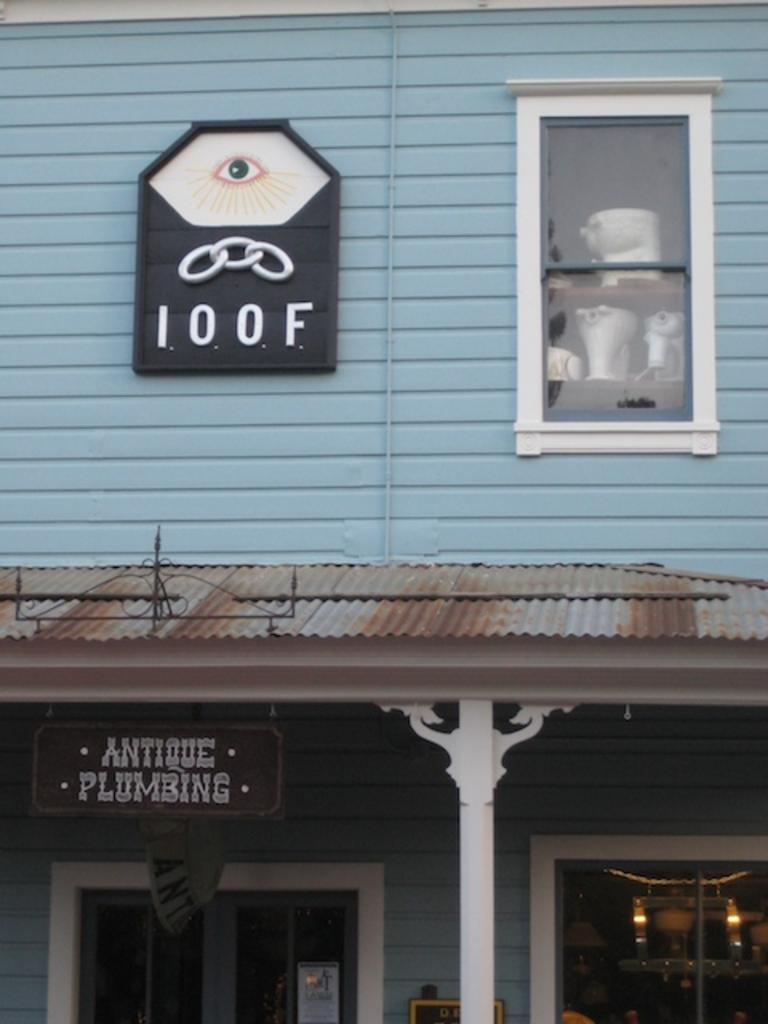<image>
Offer a succinct explanation of the picture presented. A blue building with the numbers 100F on the side. 